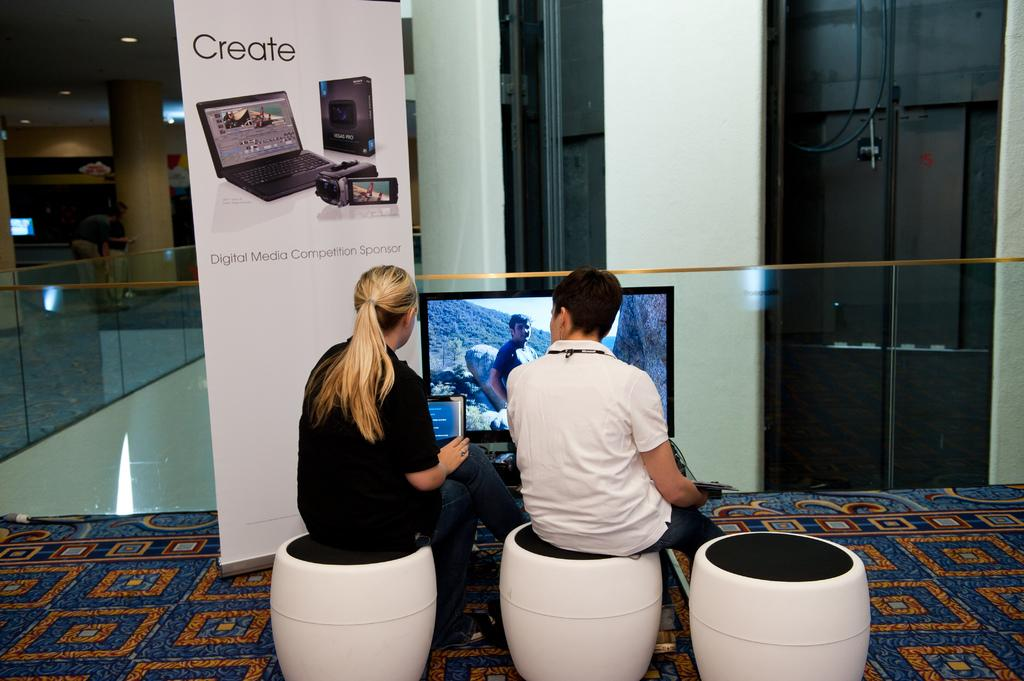<image>
Describe the image concisely. A man and a woman are sitting on seats beneath a sign that says Create. 